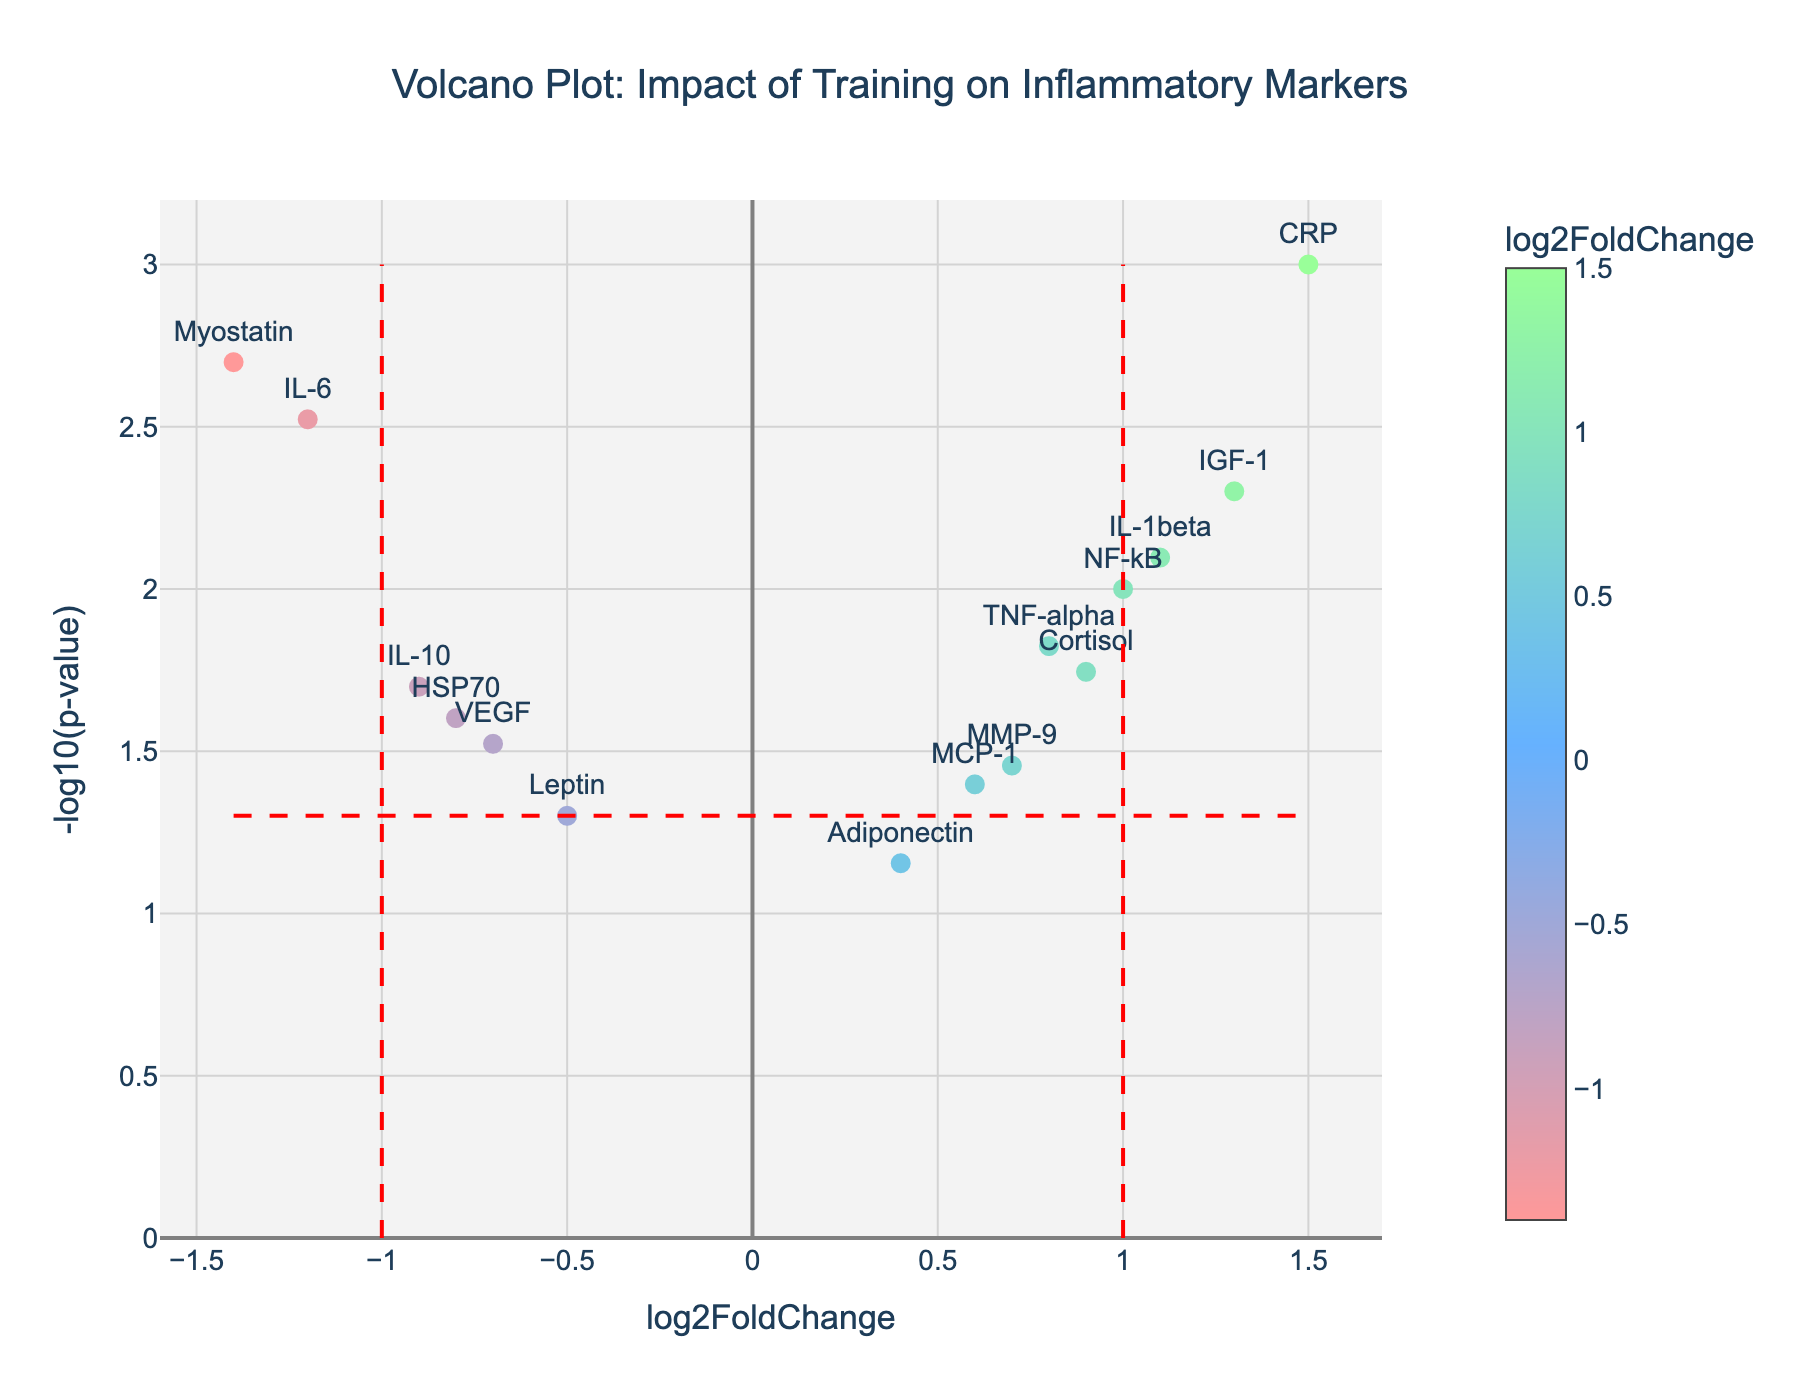What is the title of the figure? The title of the figure is usually displayed at the top center of the plot. In this figure, the title is "Volcano Plot: Impact of Training on Inflammatory Markers."
Answer: Volcano Plot: Impact of Training on Inflammatory Markers How many data points have a p-value less than 0.05? To determine the number of data points with a p-value less than 0.05, look for those points that are above the horizontal red dashed line (which represents y = -log10(0.05)). From the plot, there are 12 such points.
Answer: 12 Which gene has the highest log2FoldChange? The highest log2FoldChange value can be found by identifying the data point that is furthest to the right on the x-axis. From the plot, the gene with the highest log2FoldChange is CRP with a value of 1.5.
Answer: CRP Which gene has the lowest p-value? The lowest p-value corresponds to the highest value in the -log10(p-value) transformation. The point that is highest on the y-axis is CRP with a p-value of 0.001, so CRP has the lowest p-value.
Answer: CRP Are any genes both significantly increased and have a large fold change? Genes that are significantly increased have p-values less than 0.05 and large positive log2FoldChange values (greater than 1). From the plot, CRP, IGF-1, and IL-1beta fit these criteria.
Answer: CRP, IGF-1, IL-1beta Which genes are significantly decreased? Significantly decreased genes have p-values less than 0.05 and negative log2FoldChange values (less than -1). From the plot, IL-6 and Myostatin are the significantly decreased genes.
Answer: IL-6, Myostatin Which gene has the smallest (most negative) log2FoldChange? The most negative log2FoldChange value is the point furthest to the left on the x-axis. Myostatin has the smallest log2FoldChange of -1.4.
Answer: Myostatin What can you say about the gene Adiponectin based on the plot? By looking at the plot, Adiponectin has a log2FoldChange of 0.4 and a p-value of 0.07. Since the p-value is higher than 0.05, it's not considered statistically significant.
Answer: Not statistically significant How many genes have a log2FoldChange between -1 and 1 and p-value less than 0.05? To find the number of genes with log2FoldChange between -1 and 1 and p-value less than 0.05, focus on points within the central region (between the vertical red dashed lines) and above the horizontal red dashed line. There are 7 such genes.
Answer: 7 